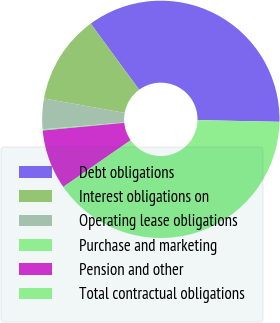<chart> <loc_0><loc_0><loc_500><loc_500><pie_chart><fcel>Debt obligations<fcel>Interest obligations on<fcel>Operating lease obligations<fcel>Purchase and marketing<fcel>Pension and other<fcel>Total contractual obligations<nl><fcel>35.39%<fcel>12.12%<fcel>4.15%<fcel>0.17%<fcel>8.14%<fcel>40.02%<nl></chart> 